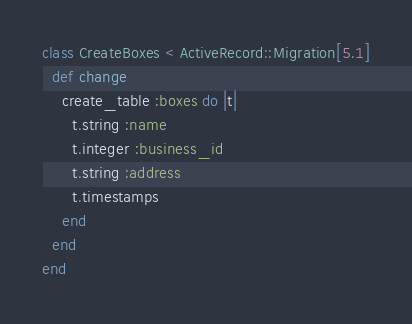<code> <loc_0><loc_0><loc_500><loc_500><_Ruby_>class CreateBoxes < ActiveRecord::Migration[5.1]
  def change
    create_table :boxes do |t|
      t.string :name
      t.integer :business_id
      t.string :address
      t.timestamps
    end
  end
end
</code> 